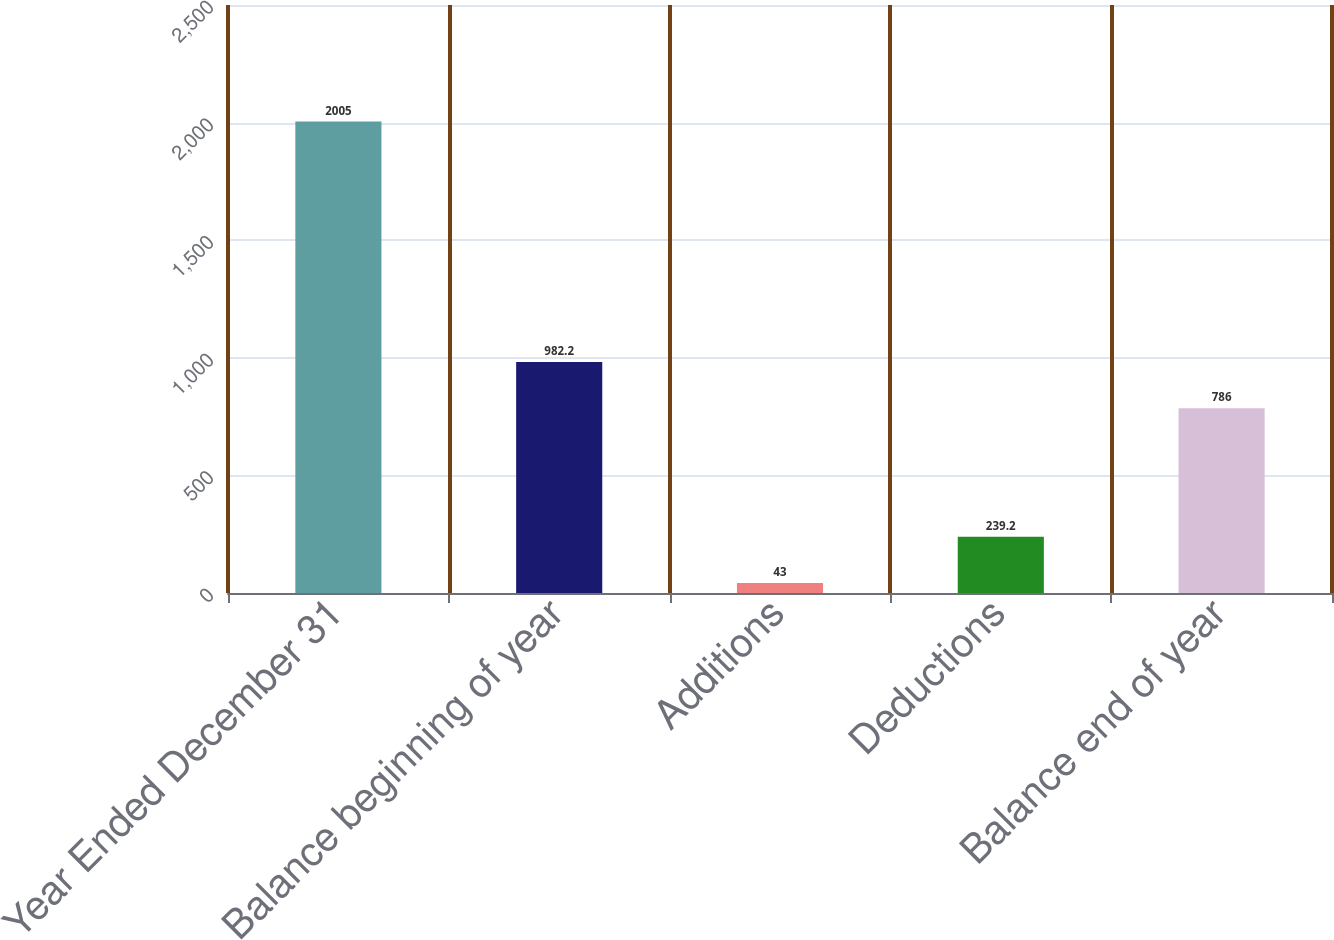<chart> <loc_0><loc_0><loc_500><loc_500><bar_chart><fcel>Year Ended December 31<fcel>Balance beginning of year<fcel>Additions<fcel>Deductions<fcel>Balance end of year<nl><fcel>2005<fcel>982.2<fcel>43<fcel>239.2<fcel>786<nl></chart> 